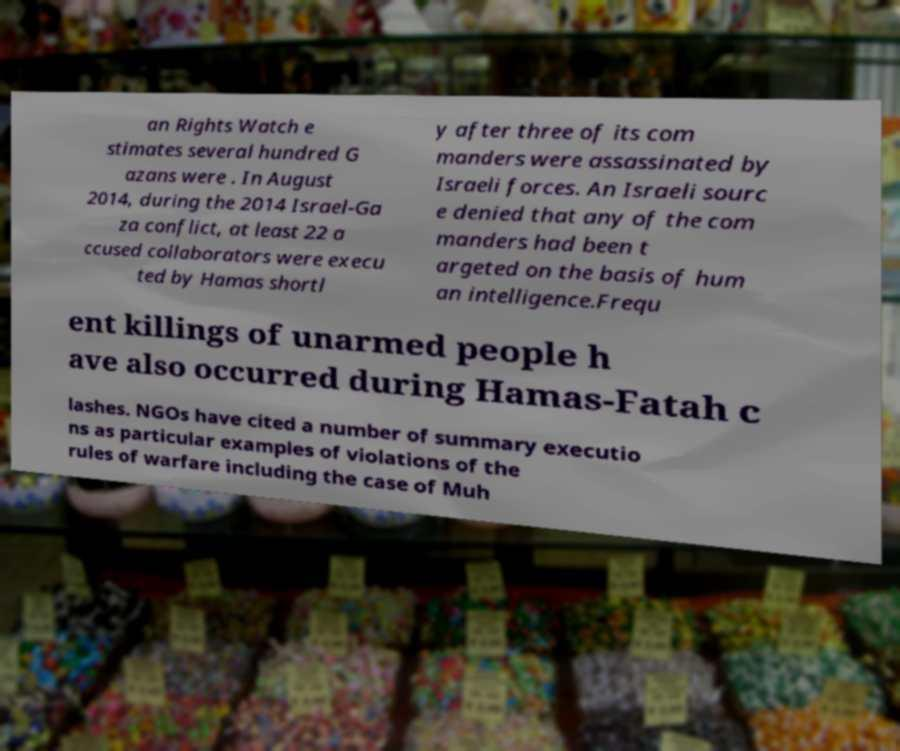For documentation purposes, I need the text within this image transcribed. Could you provide that? an Rights Watch e stimates several hundred G azans were . In August 2014, during the 2014 Israel-Ga za conflict, at least 22 a ccused collaborators were execu ted by Hamas shortl y after three of its com manders were assassinated by Israeli forces. An Israeli sourc e denied that any of the com manders had been t argeted on the basis of hum an intelligence.Frequ ent killings of unarmed people h ave also occurred during Hamas-Fatah c lashes. NGOs have cited a number of summary executio ns as particular examples of violations of the rules of warfare including the case of Muh 